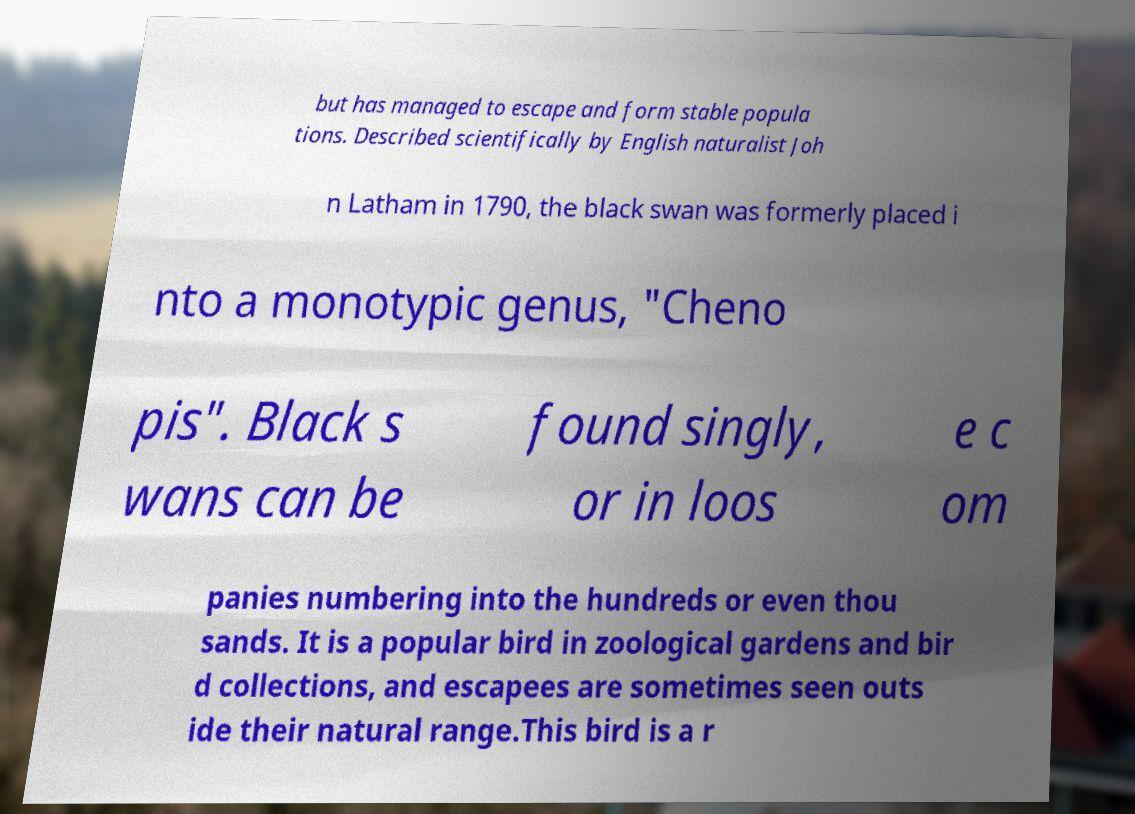For documentation purposes, I need the text within this image transcribed. Could you provide that? but has managed to escape and form stable popula tions. Described scientifically by English naturalist Joh n Latham in 1790, the black swan was formerly placed i nto a monotypic genus, "Cheno pis". Black s wans can be found singly, or in loos e c om panies numbering into the hundreds or even thou sands. It is a popular bird in zoological gardens and bir d collections, and escapees are sometimes seen outs ide their natural range.This bird is a r 